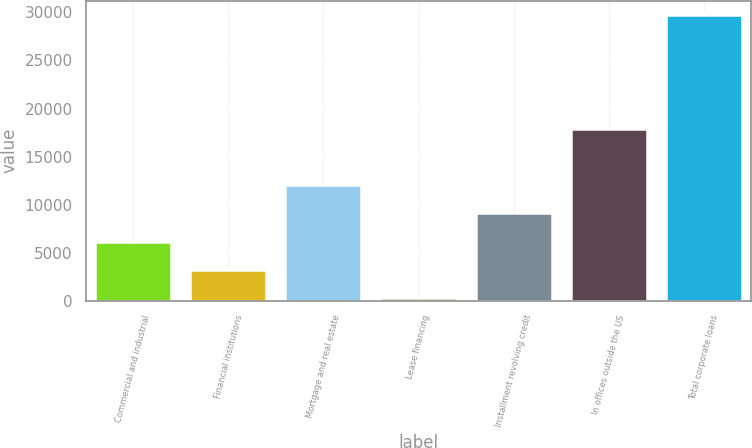Convert chart. <chart><loc_0><loc_0><loc_500><loc_500><bar_chart><fcel>Commercial and industrial<fcel>Financial institutions<fcel>Mortgage and real estate<fcel>Lease financing<fcel>Installment revolving credit<fcel>In offices outside the US<fcel>Total corporate loans<nl><fcel>6134.6<fcel>3186.8<fcel>12030.2<fcel>239<fcel>9082.4<fcel>17895<fcel>29717<nl></chart> 